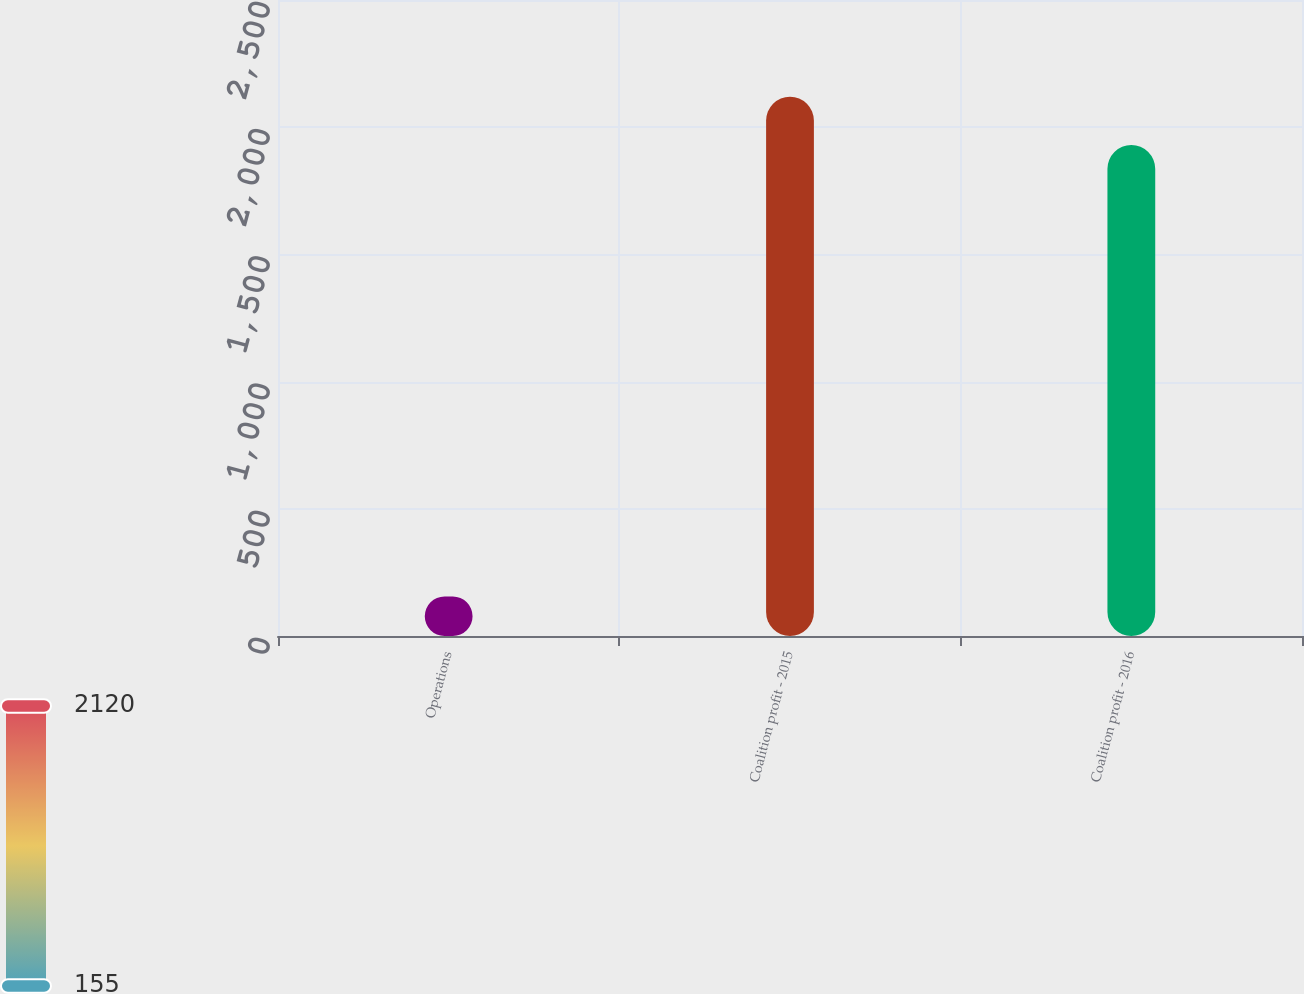<chart> <loc_0><loc_0><loc_500><loc_500><bar_chart><fcel>Operations<fcel>Coalition profit - 2015<fcel>Coalition profit - 2016<nl><fcel>154.9<fcel>2120.12<fcel>1930.2<nl></chart> 